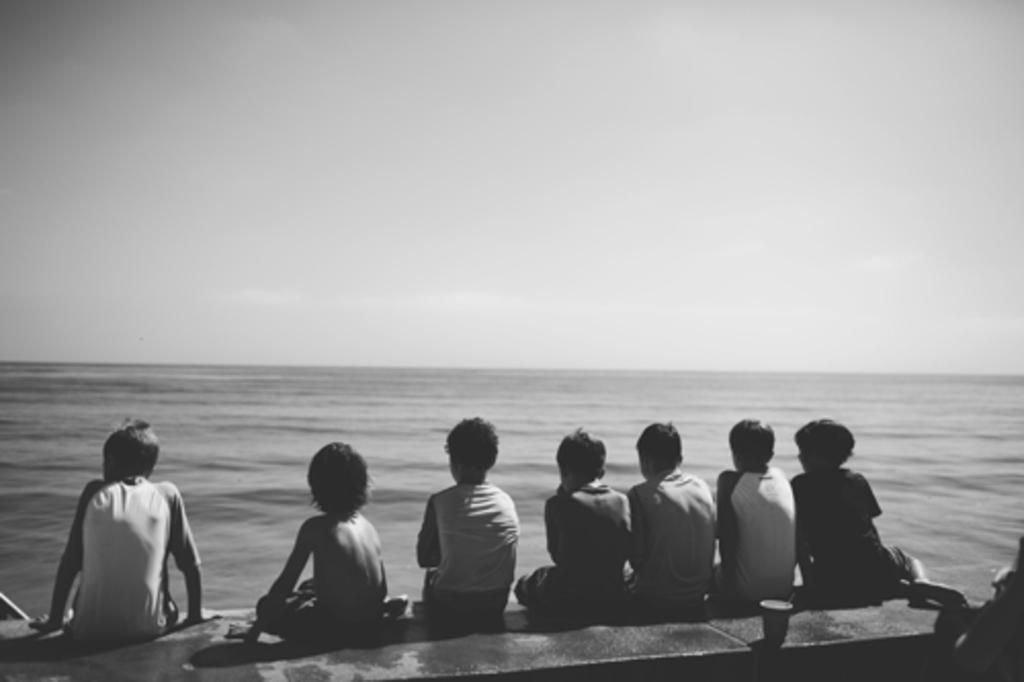What are the people in the image doing? The people in the image are sitting on a platform. What object can be seen in the image that is typically used for drinking? There is a glass visible in the image. What can be seen in the distance behind the people? There is water in the background of the image. What else is visible in the background of the image? The sky is visible in the background of the image. How many mice are crawling on the sheet in the image? There are no mice or sheets present in the image. 